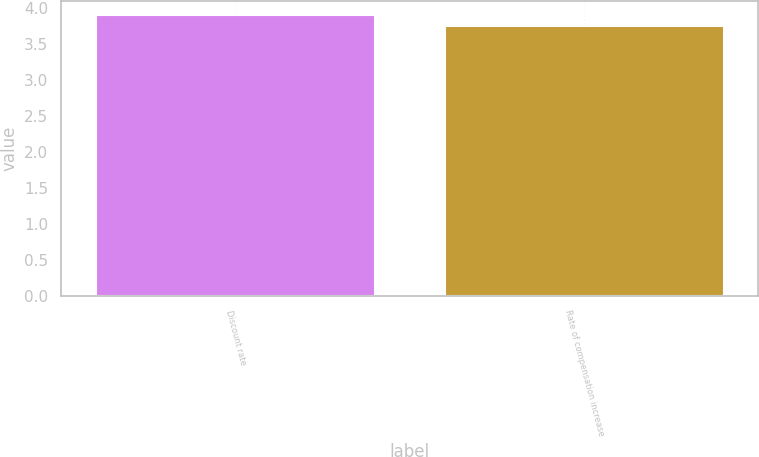Convert chart to OTSL. <chart><loc_0><loc_0><loc_500><loc_500><bar_chart><fcel>Discount rate<fcel>Rate of compensation increase<nl><fcel>3.9<fcel>3.75<nl></chart> 